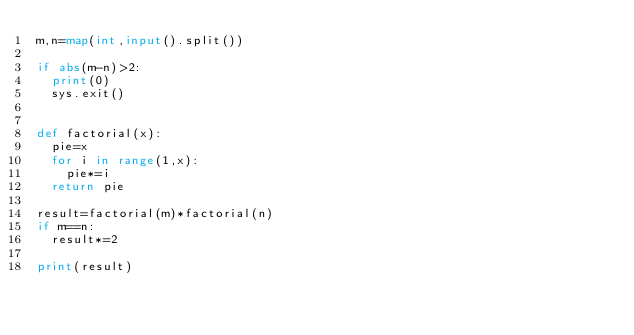<code> <loc_0><loc_0><loc_500><loc_500><_Python_>m,n=map(int,input().split())

if abs(m-n)>2:
  print(0)
  sys.exit()


def factorial(x):
  pie=x
  for i in range(1,x):
    pie*=i
  return pie

result=factorial(m)*factorial(n)
if m==n:
  result*=2

print(result)</code> 